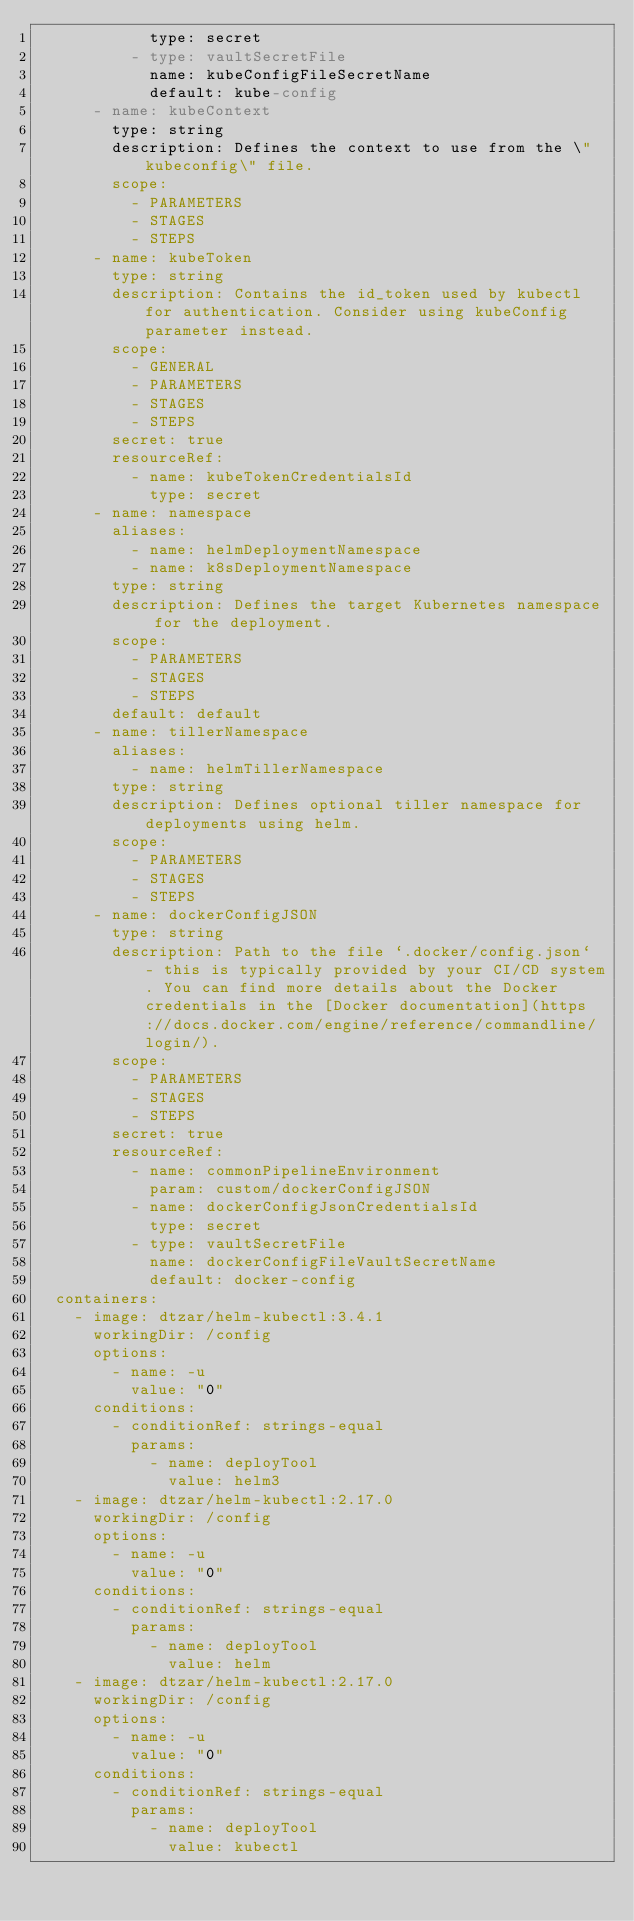Convert code to text. <code><loc_0><loc_0><loc_500><loc_500><_YAML_>            type: secret
          - type: vaultSecretFile
            name: kubeConfigFileSecretName
            default: kube-config
      - name: kubeContext
        type: string
        description: Defines the context to use from the \"kubeconfig\" file.
        scope:
          - PARAMETERS
          - STAGES
          - STEPS
      - name: kubeToken
        type: string
        description: Contains the id_token used by kubectl for authentication. Consider using kubeConfig parameter instead.
        scope:
          - GENERAL
          - PARAMETERS
          - STAGES
          - STEPS
        secret: true
        resourceRef:
          - name: kubeTokenCredentialsId
            type: secret
      - name: namespace
        aliases:
          - name: helmDeploymentNamespace
          - name: k8sDeploymentNamespace
        type: string
        description: Defines the target Kubernetes namespace for the deployment.
        scope:
          - PARAMETERS
          - STAGES
          - STEPS
        default: default
      - name: tillerNamespace
        aliases:
          - name: helmTillerNamespace
        type: string
        description: Defines optional tiller namespace for deployments using helm.
        scope:
          - PARAMETERS
          - STAGES
          - STEPS
      - name: dockerConfigJSON
        type: string
        description: Path to the file `.docker/config.json` - this is typically provided by your CI/CD system. You can find more details about the Docker credentials in the [Docker documentation](https://docs.docker.com/engine/reference/commandline/login/).
        scope:
          - PARAMETERS
          - STAGES
          - STEPS
        secret: true
        resourceRef:
          - name: commonPipelineEnvironment
            param: custom/dockerConfigJSON
          - name: dockerConfigJsonCredentialsId
            type: secret
          - type: vaultSecretFile
            name: dockerConfigFileVaultSecretName
            default: docker-config
  containers:
    - image: dtzar/helm-kubectl:3.4.1
      workingDir: /config
      options:
        - name: -u
          value: "0"
      conditions:
        - conditionRef: strings-equal
          params:
            - name: deployTool
              value: helm3
    - image: dtzar/helm-kubectl:2.17.0
      workingDir: /config
      options:
        - name: -u
          value: "0"
      conditions:
        - conditionRef: strings-equal
          params:
            - name: deployTool
              value: helm
    - image: dtzar/helm-kubectl:2.17.0
      workingDir: /config
      options:
        - name: -u
          value: "0"
      conditions:
        - conditionRef: strings-equal
          params:
            - name: deployTool
              value: kubectl
</code> 